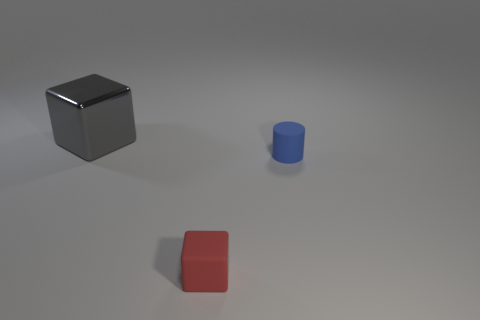What is the material of the cube that is in front of the cube behind the small red matte object?
Make the answer very short. Rubber. Does the cube in front of the metallic object have the same material as the large block?
Give a very brief answer. No. Is the size of the cube that is on the right side of the gray shiny thing the same as the big metal block?
Offer a terse response. No. Is the red matte thing the same shape as the gray metal thing?
Provide a short and direct response. Yes. The gray cube has what size?
Offer a terse response. Large. Is there another blue object that has the same size as the blue rubber thing?
Provide a succinct answer. No. What is the color of the small cylinder that is made of the same material as the tiny block?
Give a very brief answer. Blue. What material is the big gray block?
Provide a succinct answer. Metal. What shape is the blue rubber object?
Provide a short and direct response. Cylinder. What is the material of the small object that is to the right of the rubber thing on the left side of the small matte thing behind the tiny block?
Offer a terse response. Rubber. 